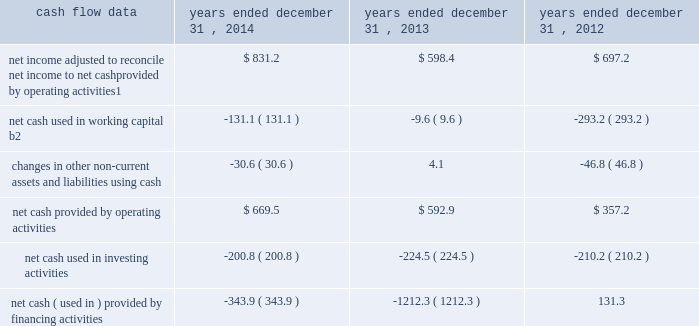Management 2019s discussion and analysis of financial condition and results of operations 2013 ( continued ) ( amounts in millions , except per share amounts ) corporate and other expenses increased slightly during 2013 by $ 3.5 to $ 140.8 compared to 2012 , primarily due to an increase in salaries and related expenses , mainly attributable to higher base salaries , benefits and temporary help , partially offset by lower severance expenses and a decrease in office and general expenses .
Liquidity and capital resources cash flow overview the tables summarize key financial data relating to our liquidity , capital resources and uses of capital. .
1 reflects net income adjusted primarily for depreciation and amortization of fixed assets and intangible assets , amortization of restricted stock and other non-cash compensation , non-cash ( gain ) loss related to early extinguishment of debt , and deferred income taxes .
2 reflects changes in accounts receivable , expenditures billable to clients , other current assets , accounts payable and accrued liabilities .
Operating activities net cash provided by operating activities during 2014 was $ 669.5 , which was an improvement of $ 76.6 as compared to 2013 , primarily as a result of an increase in net income , offset by an increase in working capital usage of $ 121.5 .
Due to the seasonality of our business , we typically generate cash from working capital in the second half of a year and use cash from working capital in the first half of a year , with the largest impacts in the first and fourth quarters .
Our net working capital usage in 2014 was impacted by our media businesses .
Net cash provided by operating activities during 2013 was $ 592.9 , which was an increase of $ 235.7 as compared to 2012 , primarily as a result of an improvement in working capital usage of $ 283.6 , offset by a decrease in net income .
The improvement in working capital in 2013 was impacted by our media businesses and an ongoing focus on working capital management at our agencies .
The timing of media buying on behalf of our clients affects our working capital and operating cash flow .
In most of our businesses , our agencies enter into commitments to pay production and media costs on behalf of clients .
To the extent possible we pay production and media charges after we have received funds from our clients .
The amounts involved substantially exceed our revenues and primarily affect the level of accounts receivable , expenditures billable to clients , accounts payable and accrued liabilities .
Our assets include both cash received and accounts receivable from clients for these pass-through arrangements , while our liabilities include amounts owed on behalf of clients to media and production suppliers .
Our accrued liabilities are also affected by the timing of certain other payments .
For example , while annual cash incentive awards are accrued throughout the year , they are generally paid during the first quarter of the subsequent year .
Investing activities net cash used in investing activities during 2014 primarily related to payments for capital expenditures and acquisitions .
Capital expenditures of $ 148.7 related primarily to computer hardware and software and leasehold improvements .
We made payments of $ 67.8 related to acquisitions completed during 2014 , net of cash acquired. .
By how many percent did the net cash provided by operating activities increase from 2013 to 2014? 
Computations: ((76.6 / (669.5 - 76.6)) * 100)
Answer: 12.91955. 